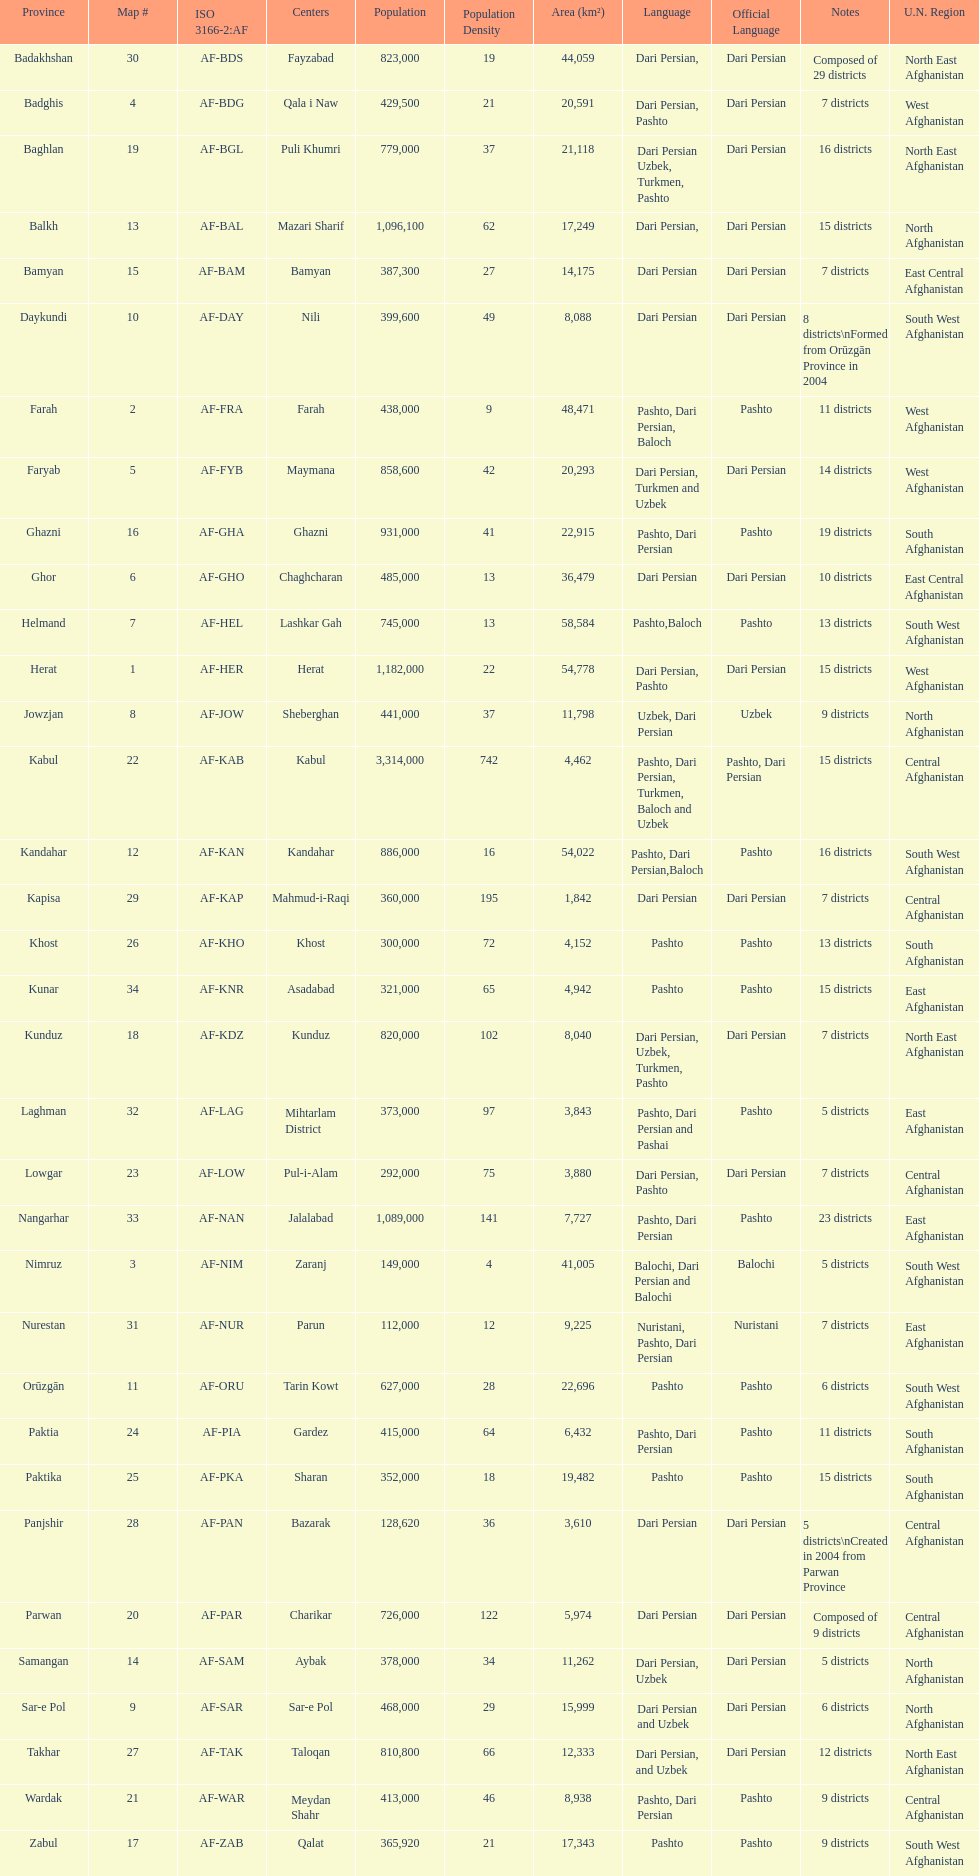How many provinces have the same number of districts as kabul? 4. 